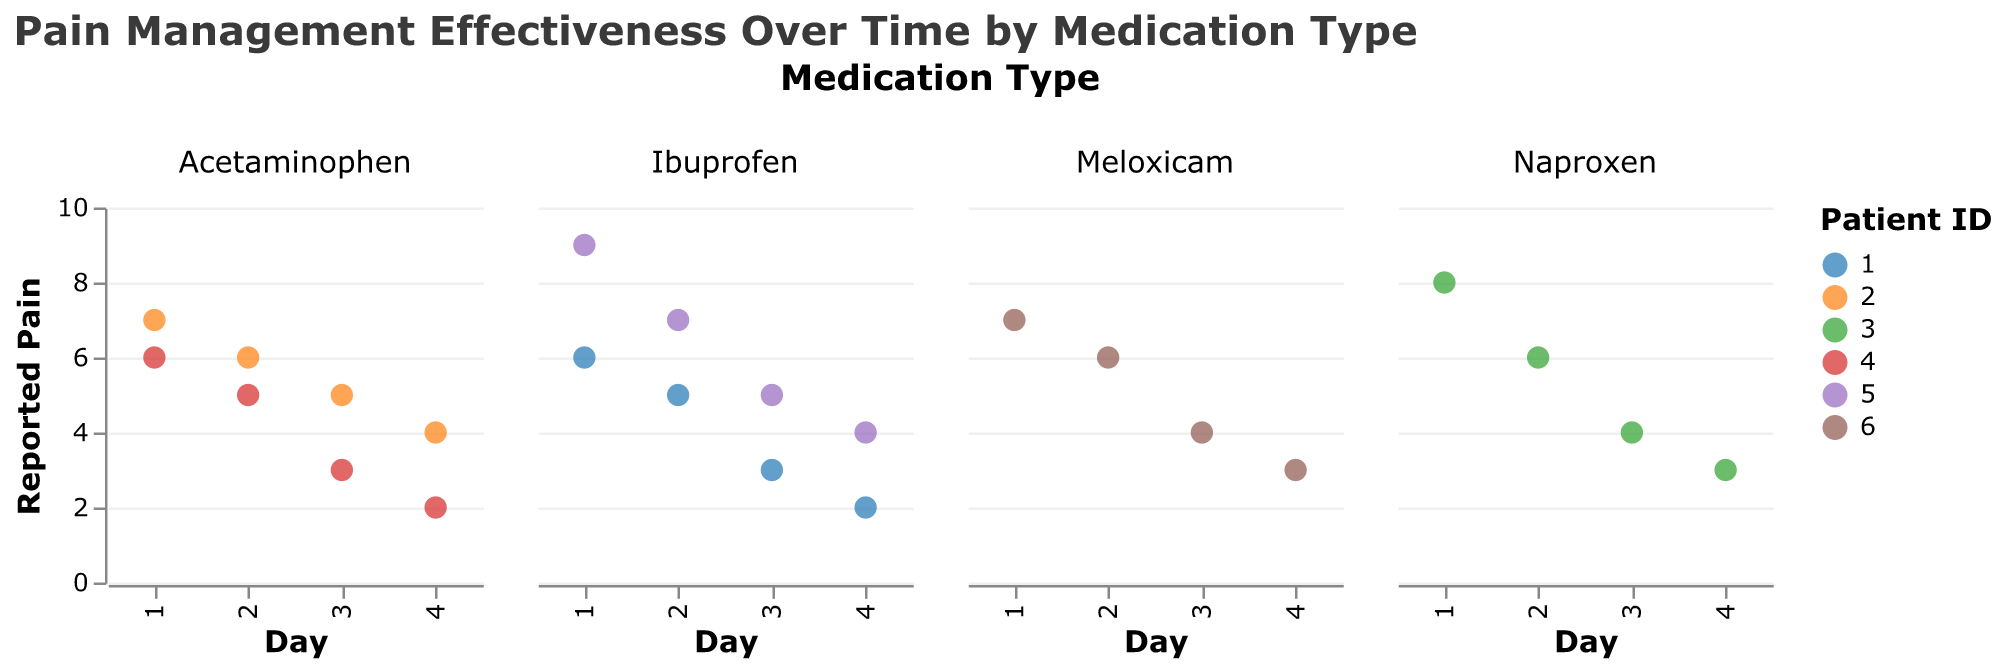What is the title of the plot? The title of the plot is usually located at the top of the figure; it provides a general description of what the plot represents. In this case, the title is "Pain Management Effectiveness Over Time by Medication Type."
Answer: Pain Management Effectiveness Over Time by Medication Type How many different medication types are shown in the plot? The plot shows separate subplots or facets for each medication type. By counting the distinct columns or subplots, we can identify the number of different medication types.
Answer: Four Which medication type shows the highest reported pain on Day 1? To find the answer, locate Day 1 on the x-axis for each subplot and identify the highest y-axis value corresponding to Day 1.
Answer: Naproxen How does the reported pain level change over time for patient 1 using Ibuprofen? For patient 1 under Ibuprofen, observe the data points across Days 1 to 4 within the Ibuprofen subplot and note the trend. The trend indicates a decrease in pain level over time.
Answer: Decreases Which medication type had the most consistent decrease in pain over the four days? By observing all subplots for each medication type, assess which one shows a steady, consistent decrease in reported pain from Day 1 to Day 4 for all patients.
Answer: Acetaminophen What is the average reported pain for patients taking Meloxicam on Day 3? Identify all data points for Meloxicam on Day 3 and calculate the average by adding the reported pain values and dividing by the number of patients.
Answer: 4 Which patient had the sharpest drop in reported pain by Day 4? Look for the data points where the difference in reported pain between Day 1 and Day 4 is the largest across all subplots.
Answer: Patient 5 (Ibuprofen) Does the plot suggest that any medication type is ineffective by Day 4? Review all subplots on Day 4 and compare the reported pain levels to determine if there's any medication type where reported pain remains high or does not show a significant drop.
Answer: No 